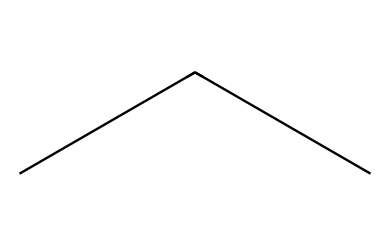How many carbon atoms are in this molecule? The SMILES representation "CCC" shows a linear arrangement of three carbon atoms connected to each other. Each 'C' represents one carbon atom. Therefore, counting the 'C' characters gives us three carbon atoms.
Answer: 3 What is the chemical name of this refrigerant? The SMILES notation "CCC" corresponds to propane, which is known as R-290 when used as a refrigerant. This designation is derived from its chemical structure and molecular composition.
Answer: propane How many hydrogen atoms are bonded to this chemical? Propane (R-290) has the molecular formula C3H8. Each carbon atom in propane can bond with enough hydrogen atoms to satisfy the tetravalent nature of carbon. Thus, with three carbon atoms, there are a total of eight hydrogen atoms.
Answer: 8 Is propane (R-290) a hydrocarbon? Propane consists solely of carbon and hydrogen atoms, fitting the definition of hydrocarbons, which are organic compounds made entirely of carbon and hydrogen. As it does not contain any other elements, it is classified as a hydrocarbon.
Answer: yes What type of refrigerant is propane classified as? Propane is classified as a naturally occurring refrigerant and specifically, it is known as a hydrocarbon refrigerant. This classification is due to its chemical structure and its eco-friendly properties, making it increasingly popular in refrigeration applications.
Answer: hydrocarbon 